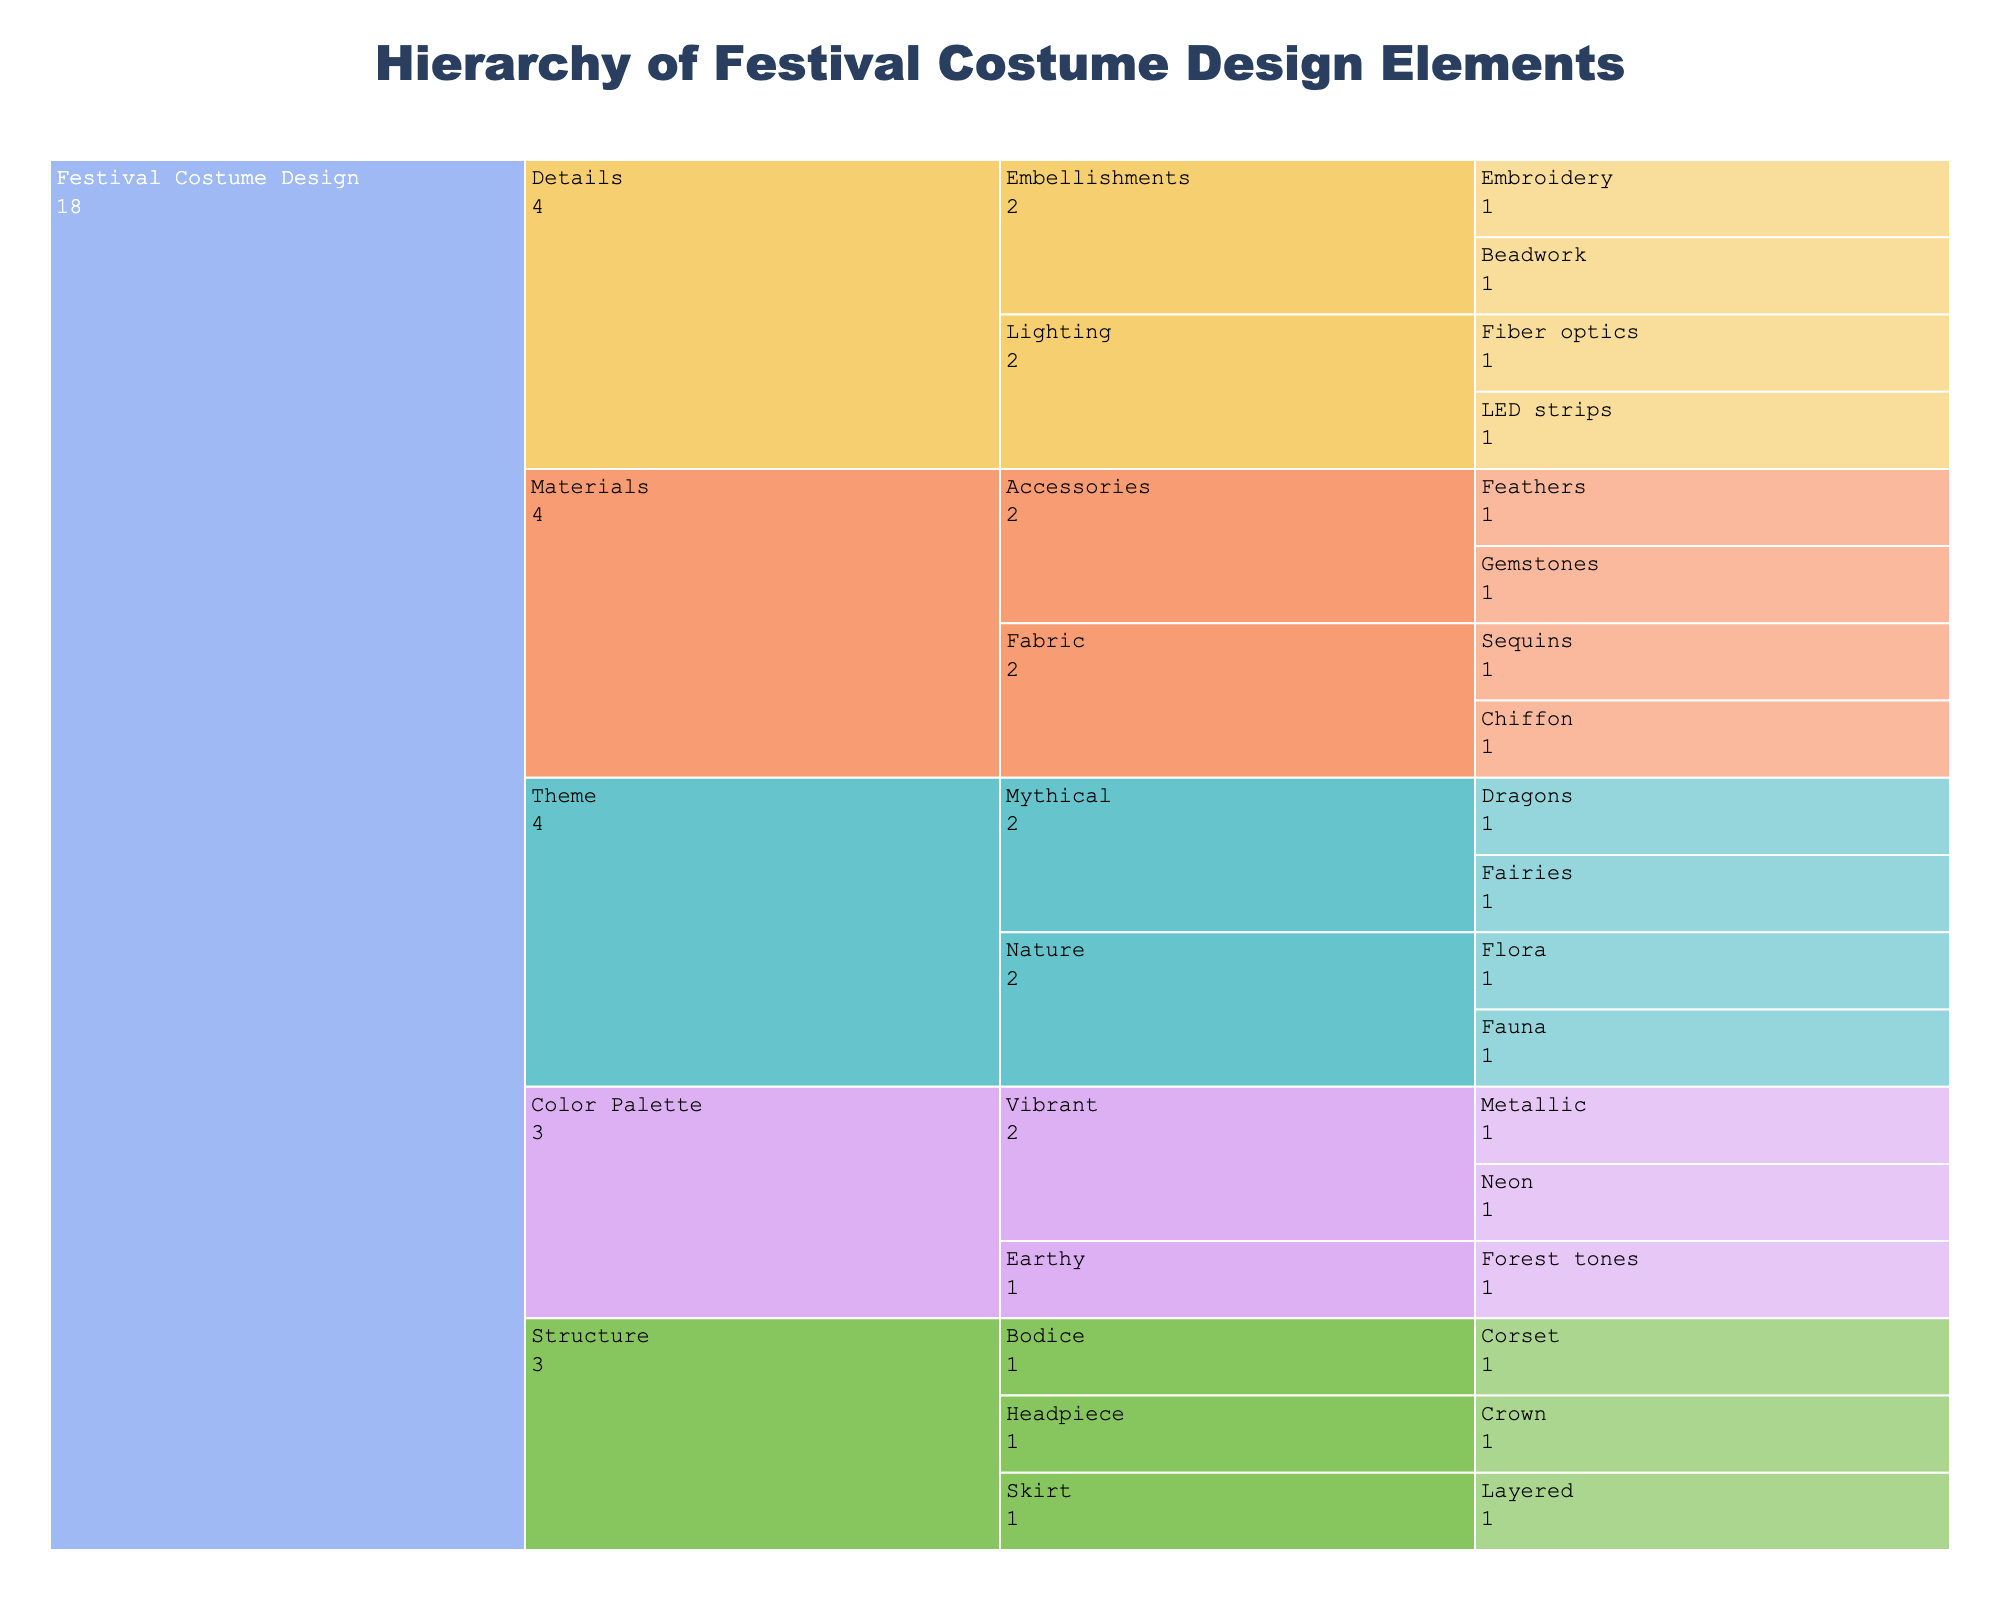What's the main title of the icicle chart? The main title is usually prominently displayed at the top of the chart. Here, it is specified in the data and code provided.
Answer: Hierarchy of Festival Costume Design Elements How many top-level categories are there in the chart? There are four top-level categories directly connected to the root in the chart: Theme, Color Palette, Materials, and Structure. These branches from the "Festival Costume Design" node.
Answer: 4 What are the subcategories under 'Theme'? By following the path starting from 'Festival Costume Design' down to 'Theme,' the subcategories under 'Theme' can be seen as 'Nature' and 'Mythical.'
Answer: Nature, Mythical What is the difference between the number of subcategories in 'Materials' and 'Color Palette'? 'Materials' have two subcategories: Fabric and Accessories. 'Color Palette' has two subcategories: Vibrant and Earthy. Both have the same number of subcategories.
Answer: 0 Which category has 'Neon' as a subcategory? By tracing the path under 'Color Palette,' 'Vibrant,' the subcategory 'Neon' is found.
Answer: Color Palette What's the total number of categories that are under 'Details'? 'Details' branch into 'Embellishments' and 'Lighting,' each of which then branches further. Counting all individual nodes beneath 'Details' results in four: Beadwork, Embroidery, LED strips, and Fiber optics.
Answer: 4 Under which top-level category does 'Feathers' fall? Tracing the ‘Materials’ category leads to 'Accessories,' under which 'Feathers' is listed.
Answer: Materials Which theme has more subcategories, 'Nature' or 'Mythical'? 'Nature' has 'Flora' and 'Fauna,' while 'Mythical' has 'Fairies' and 'Dragons.' Both 'Nature' and 'Mythical' have an equal number of subcategories.
Answer: Neither; they are equal If you sum all individual elements under 'Structure,' how many elements are there? Under 'Structure,' the subcategories are 'Bodice,' 'Skirt,' and 'Headpiece.' Each has one further subcategory: 'Corset,' 'Layered,' and 'Crown,' respectively. Summing these gives three individual elements.
Answer: 3 